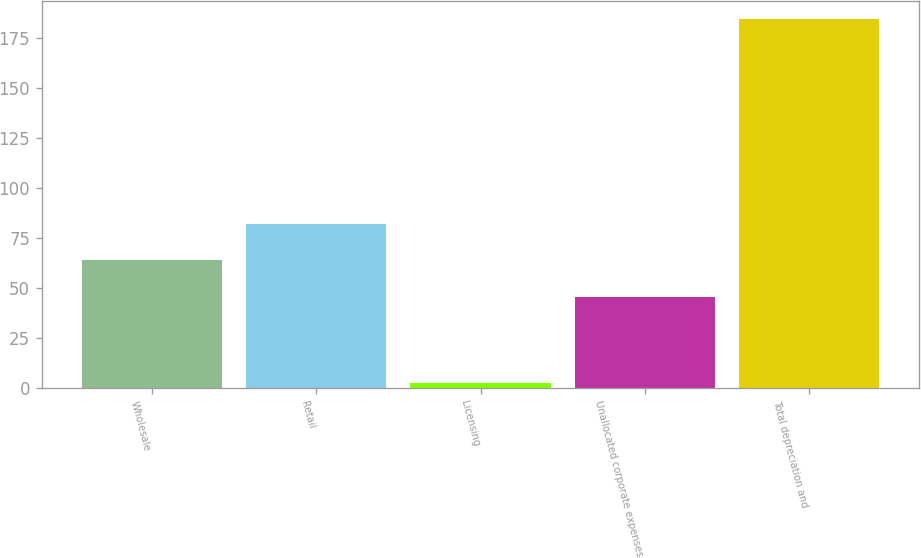Convert chart. <chart><loc_0><loc_0><loc_500><loc_500><bar_chart><fcel>Wholesale<fcel>Retail<fcel>Licensing<fcel>Unallocated corporate expenses<fcel>Total depreciation and<nl><fcel>64<fcel>82.2<fcel>2.4<fcel>45.8<fcel>184.4<nl></chart> 